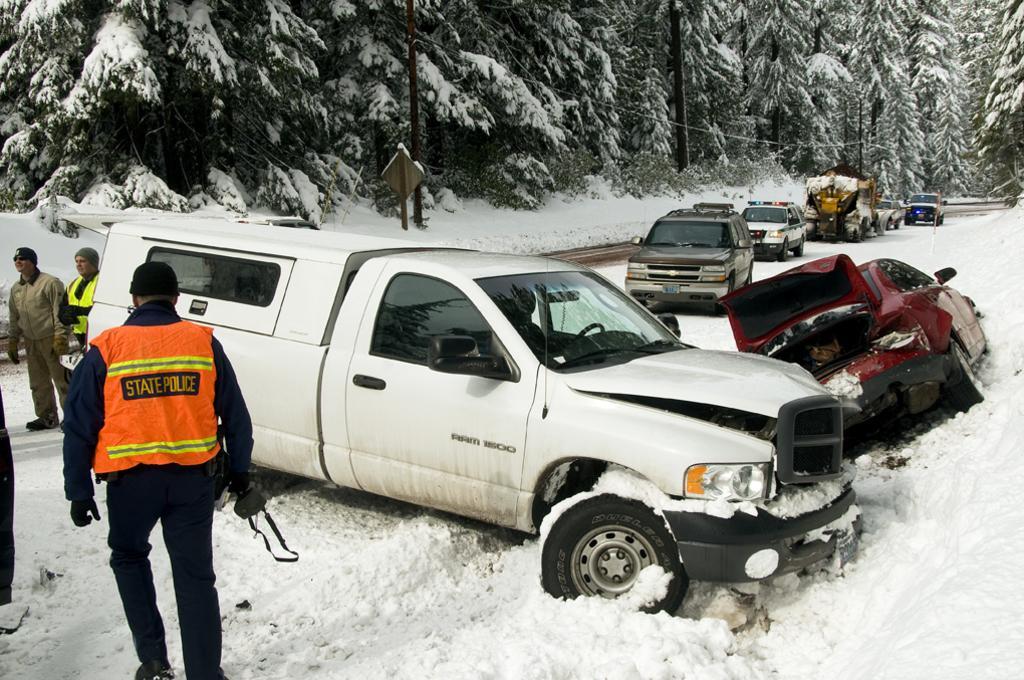Please provide a concise description of this image. In the middle it is a vehicle which is in white color. In the left side a policeman is walking, he wore an orange color coat. These are the trees, there is a snow on it. 